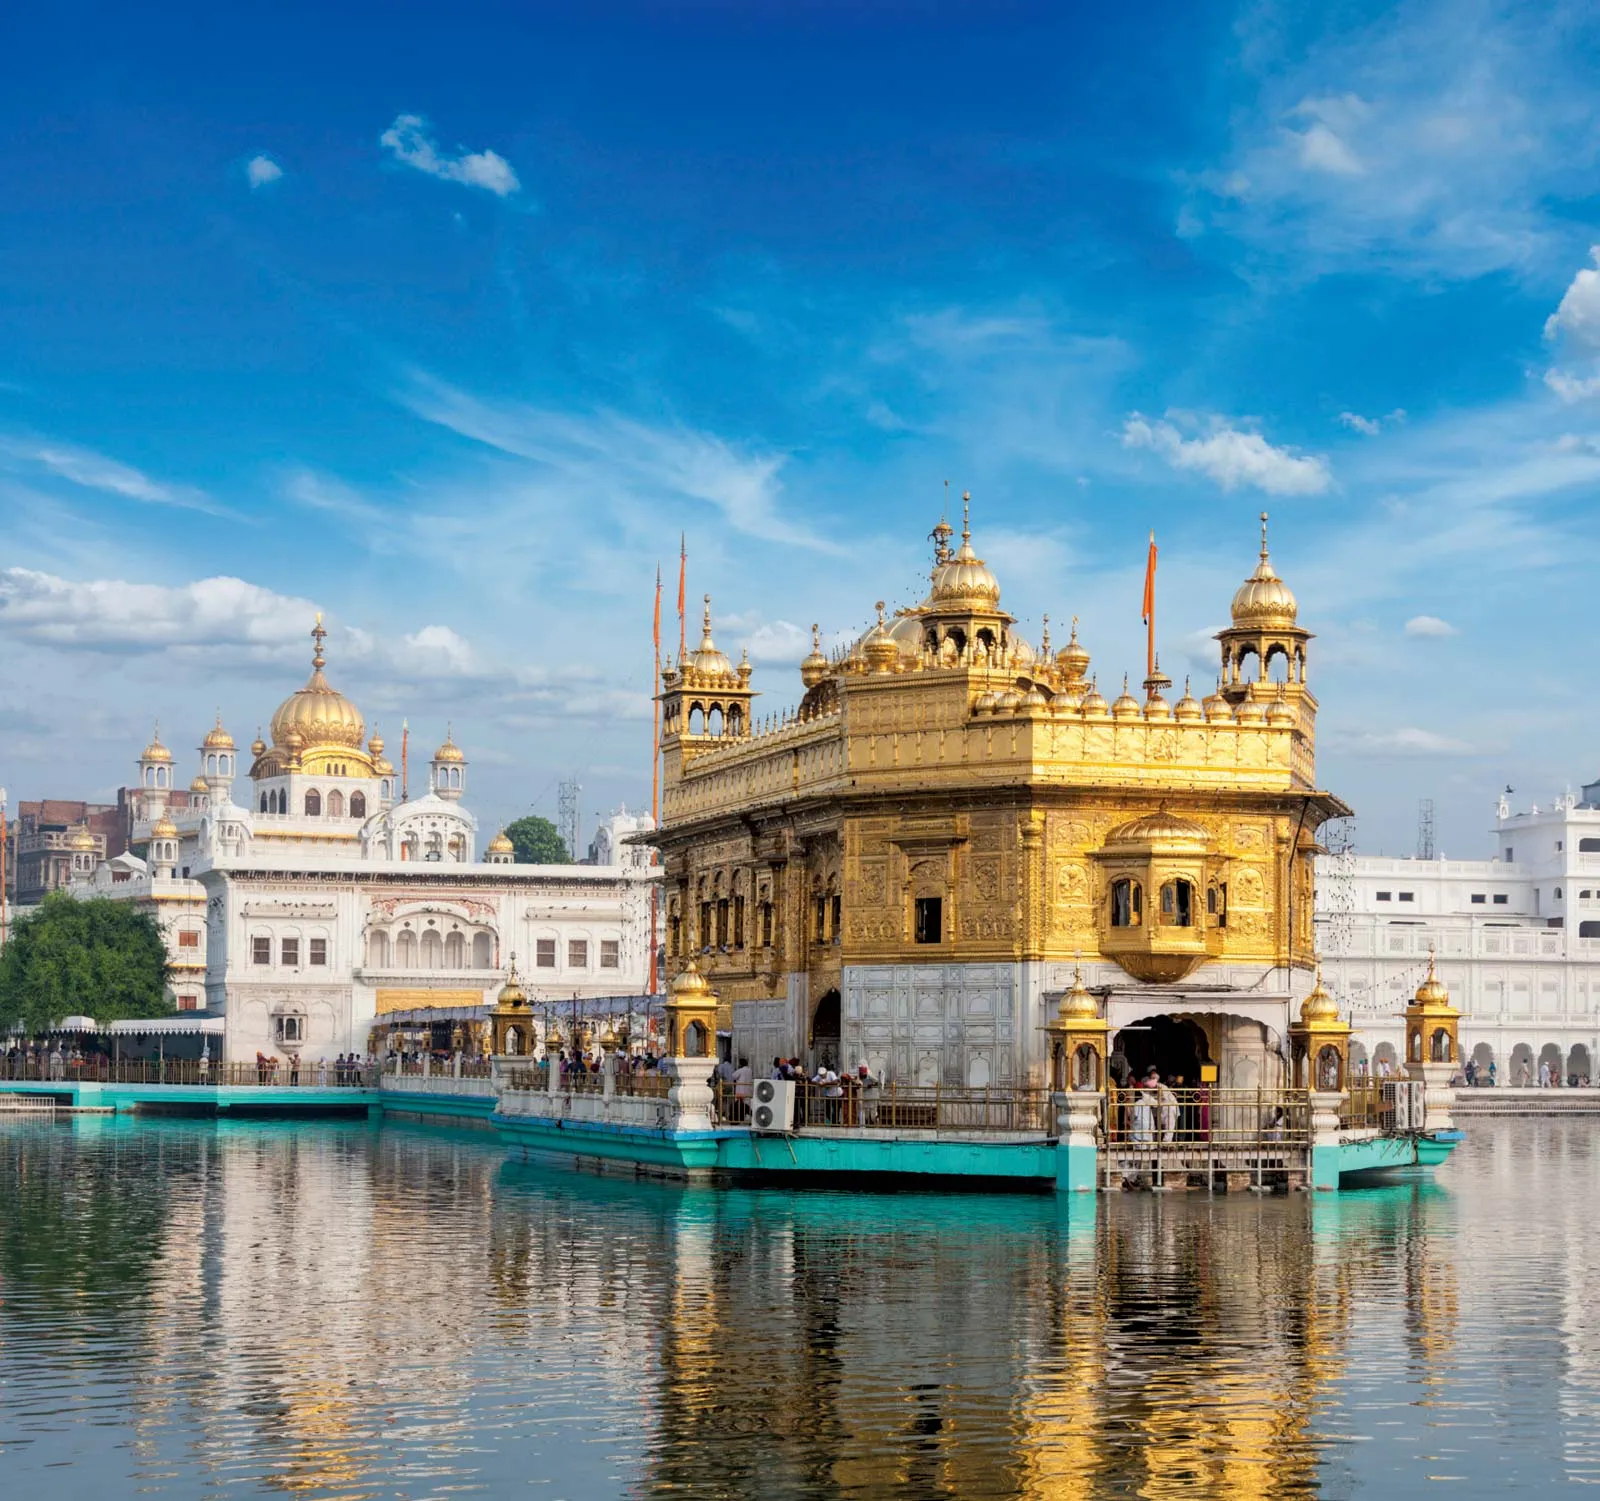How does one experience a typical day at the Golden Temple? A typical day at the Golden Temple begins early in the morning with the Asa di Var, a pre-dawn prayer session that fills the atmosphere with spiritual tranquility. Devotees take a dip in the Amrit Sarovar, believing in the purifying properties of its waters. Throughout the day, the sound of Gurbani (holy hymns) resonates within the complex, as the Guru Granth Sahib is continuously recited. The community kitchen, or Langar, operates tirelessly, offering free meals to thousands of visitors regardless of their background. Pilgrims wander around the complex, paying their respects and soaking in the serene ambiance. The Akal Takht, the temporal seat of Sikh authority, also sees a steady stream of visitors. As evening approaches, the temple is illuminated, casting a magical reflection in the surrounding waters, and the Sohila Sahib prayer marks the closing of the day. The detailed arrangement of rituals and the seamless blend of sacredness and community service create an unforgettable experience for every visitor. What other attractions can be found near the Golden Temple? Near the Golden Temple, visitors can explore several attractions that offer cultural, historical, and spiritual insights. The Jallianwala Bagh, a memorial garden that marks the site of the 1919 massacre, offers a poignant reminder of India's struggle for independence. The Partition Museum provides comprehensive exhibits on the Partition of India, showcasing personal stories and artifacts. For those interested in Sikh history, the Central Sikh Museum within the Golden Temple complex houses a collection of paintings, old coins, and ancient manuscripts. Another significant site is the Durgiana Temple, which is dedicated to the Hindu goddess Durga and shares architectural similarities with the Golden Temple. Additionally, visitors can enjoy traditional Punjabi cuisine in the vibrant local markets and shop for handicrafts, clothing, and souvenirs. The combination of these attractions ensures a culturally enriching experience for all visitors. 